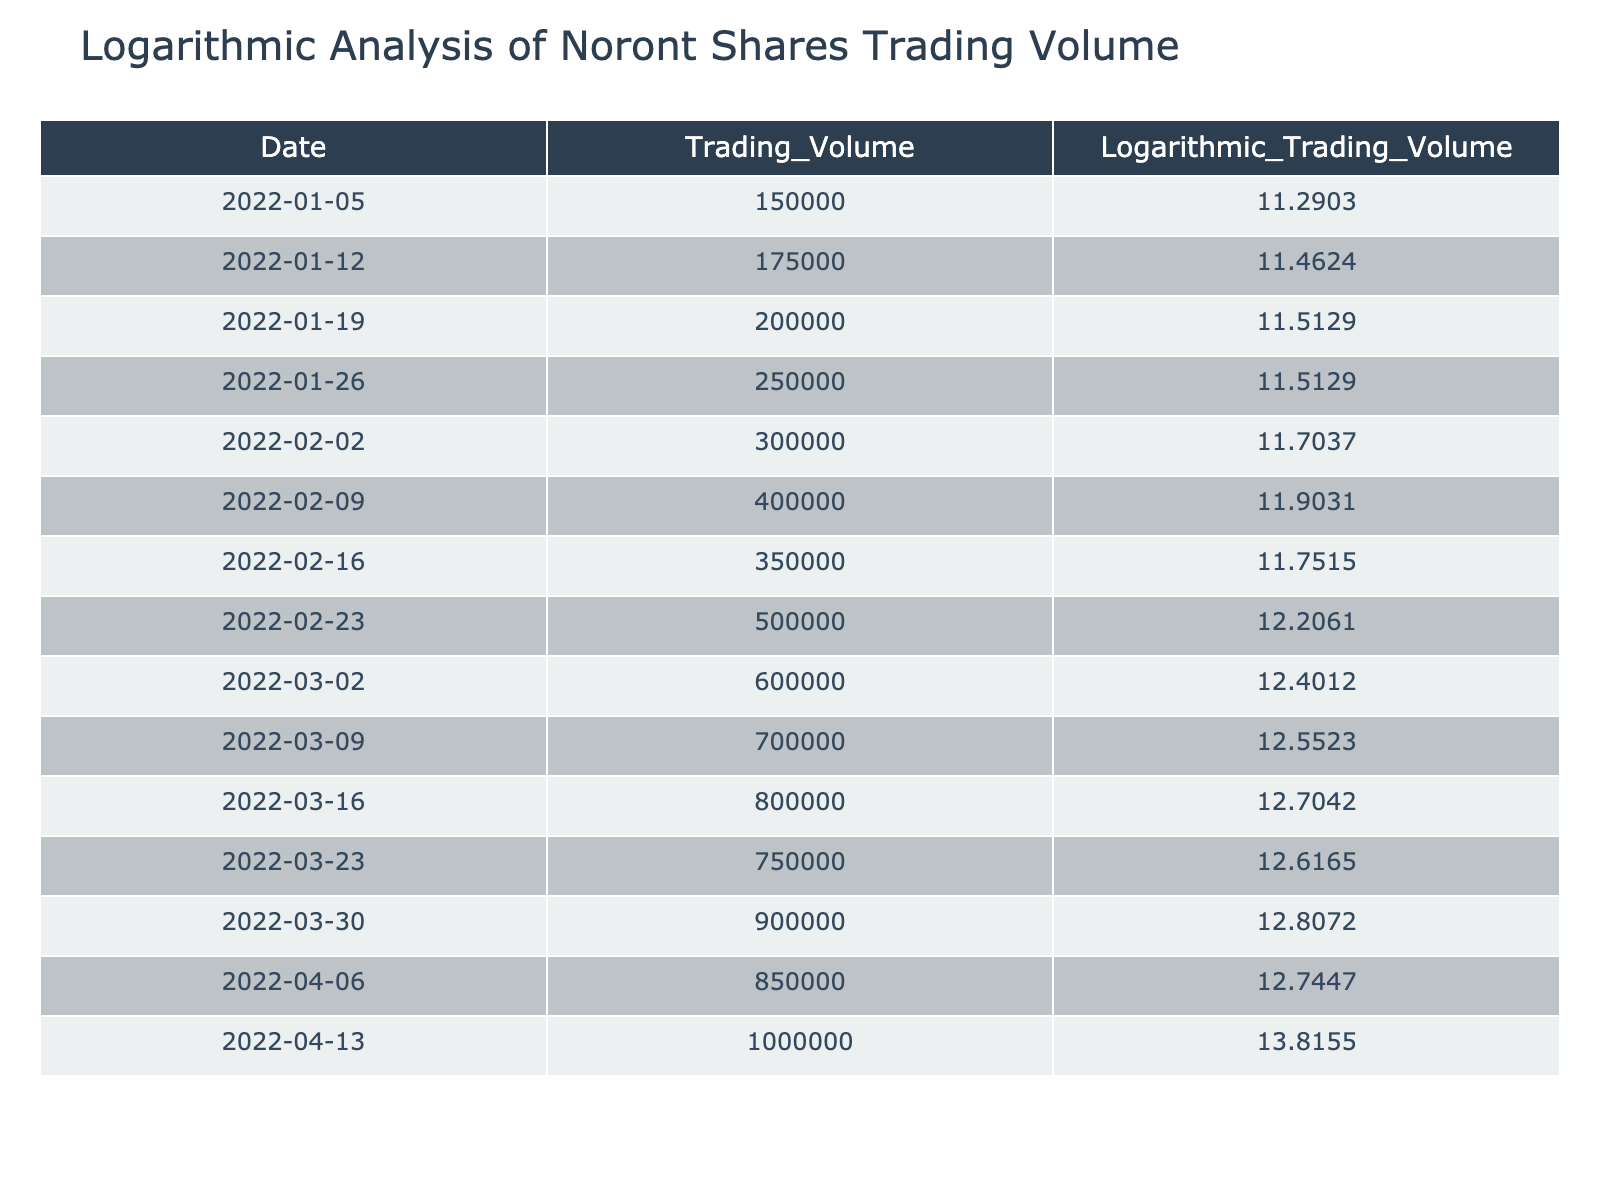What's the trading volume on January 5, 2022? Referring directly to the table, the trading volume on January 5, 2022, is listed as 150000.
Answer: 150000 What is the logarithmic trading volume for the highest trading volume recorded? The highest trading volume is 1000000 on April 13, 2022, which corresponds to a logarithmic trading volume of 13.8155.
Answer: 13.8155 How many trading days does it take to increase the trading volume from 150000 to 1000000? The trading volume increases from 150000 (January 5) to 1000000 (April 13) over a span of 14 trading days.
Answer: 14 Is the trading volume on February 16, 2022, greater than the trading volume on March 2, 2022? Looking at the table, the trading volume on February 16, 2022, is 350000 which is less than the trading volume on March 2, 2022, which is 600000. So, the statement is false.
Answer: No What was the average logarithmic trading volume over the recorded dates? To find the average, sum the logarithmic trading volumes: 11.2903 + 11.4624 + 11.5129 + 11.5129 + 11.7037 + 11.9031 + 11.7515 + 12.2061 + 12.4012 + 12.5523 + 12.7042 + 12.6165 + 12.8072 + 12.7447 + 13.8155 = 176.7456. Divide by 15 (the number of rows): 176.7456 / 15 = 11.7827.
Answer: 11.7827 What is the difference in logarithmic trading volume between the lowest and highest recorded values? The lowest logarithmic trading volume is 11.2903 (January 5, 2022) and the highest is 13.8155 (April 13, 2022). The difference is 13.8155 - 11.2903 = 2.5252.
Answer: 2.5252 